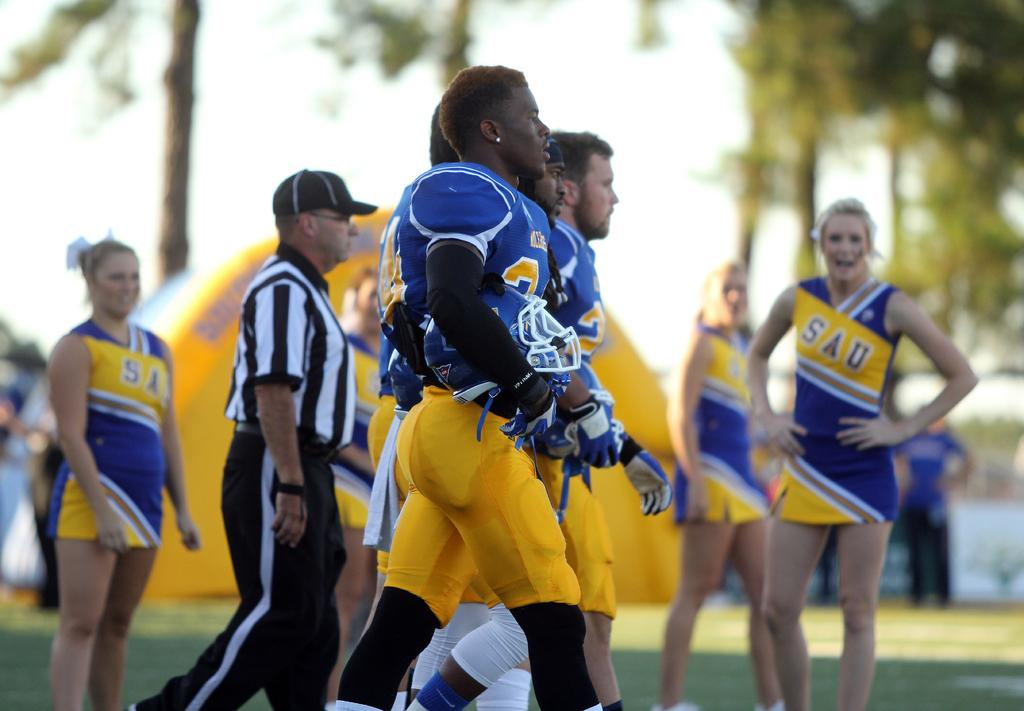<image>
Write a terse but informative summary of the picture. Cheerleaders in SAU uniforms watch football players walk by. 